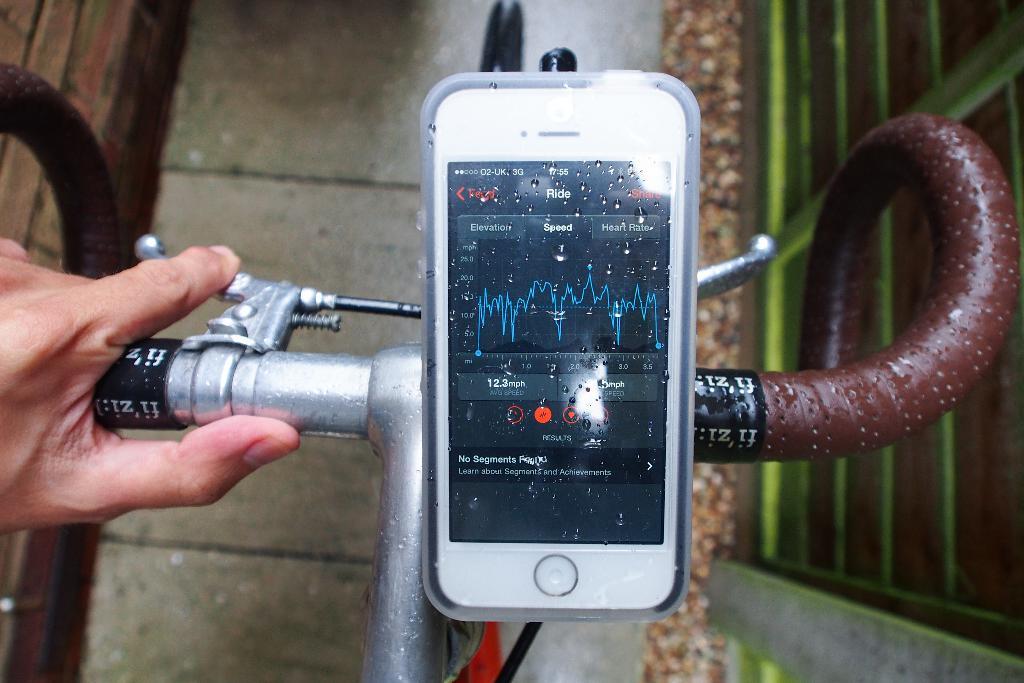What does the top of the app say?
Ensure brevity in your answer.  Ride. What does the bottom text on the screen say?
Provide a succinct answer. Learn about segments and achievements. 